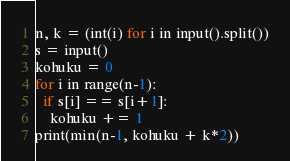Convert code to text. <code><loc_0><loc_0><loc_500><loc_500><_Python_>n, k = (int(i) for i in input().split())
s = input()
kohuku = 0
for i in range(n-1):
  if s[i] == s[i+1]:
    kohuku += 1
print(min(n-1, kohuku + k*2))</code> 